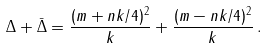Convert formula to latex. <formula><loc_0><loc_0><loc_500><loc_500>\Delta + \bar { \Delta } = \frac { ( m + n k / 4 ) ^ { 2 } } { k } + \frac { ( m - n k / 4 ) ^ { 2 } } { k } \, .</formula> 